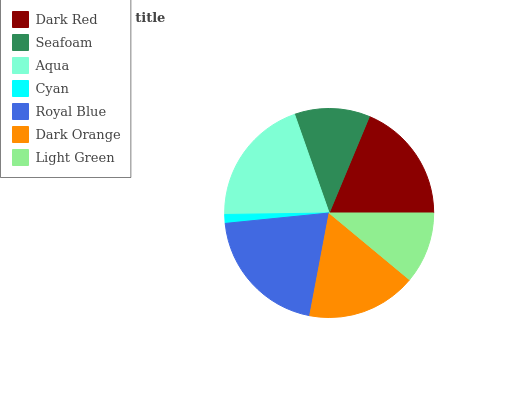Is Cyan the minimum?
Answer yes or no. Yes. Is Royal Blue the maximum?
Answer yes or no. Yes. Is Seafoam the minimum?
Answer yes or no. No. Is Seafoam the maximum?
Answer yes or no. No. Is Dark Red greater than Seafoam?
Answer yes or no. Yes. Is Seafoam less than Dark Red?
Answer yes or no. Yes. Is Seafoam greater than Dark Red?
Answer yes or no. No. Is Dark Red less than Seafoam?
Answer yes or no. No. Is Dark Orange the high median?
Answer yes or no. Yes. Is Dark Orange the low median?
Answer yes or no. Yes. Is Seafoam the high median?
Answer yes or no. No. Is Cyan the low median?
Answer yes or no. No. 